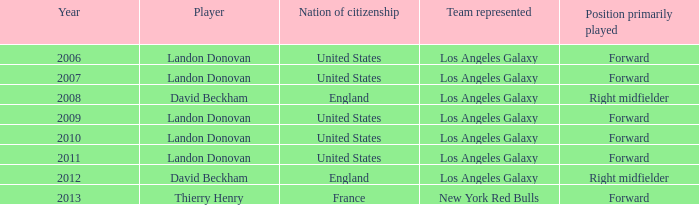What is the aggregate of all the years landon donovan was victorious in the espy award? 5.0. 